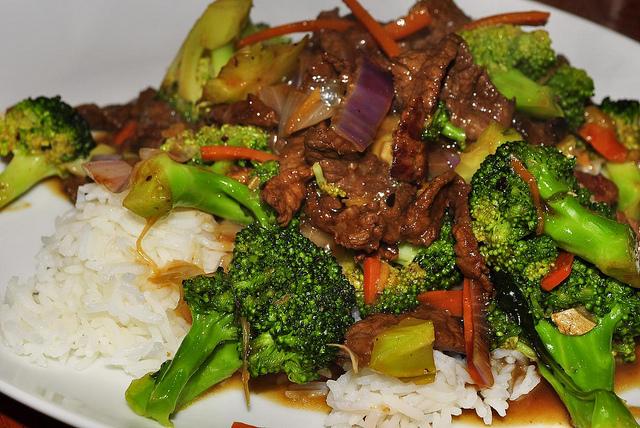Will the food cry if you eat it?
Keep it brief. No. What color is the plate?
Keep it brief. White. Is this food ethnic?
Quick response, please. Yes. 